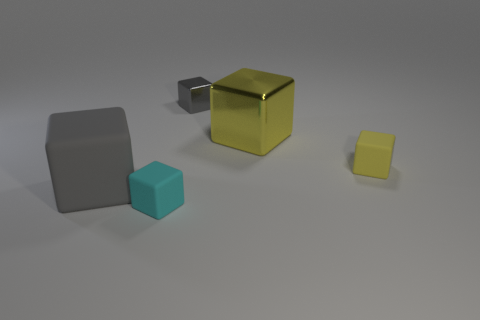Is the color of the small metallic thing the same as the large shiny object?
Offer a very short reply. No. What is the size of the object that is the same color as the big matte cube?
Your answer should be compact. Small. The large block that is the same material as the tiny cyan object is what color?
Your answer should be very brief. Gray. Are the small cyan cube and the gray block in front of the gray metal cube made of the same material?
Give a very brief answer. Yes. The large shiny cube is what color?
Your answer should be very brief. Yellow. There is a gray cube that is the same material as the big yellow thing; what size is it?
Give a very brief answer. Small. There is a small object that is behind the matte block behind the large gray block; what number of big blocks are behind it?
Make the answer very short. 0. Does the large metal object have the same color as the block left of the cyan cube?
Keep it short and to the point. No. There is a small matte thing that is the same color as the big metallic cube; what shape is it?
Give a very brief answer. Cube. There is a gray block that is on the left side of the small rubber cube in front of the matte object right of the large yellow shiny cube; what is it made of?
Provide a succinct answer. Rubber. 